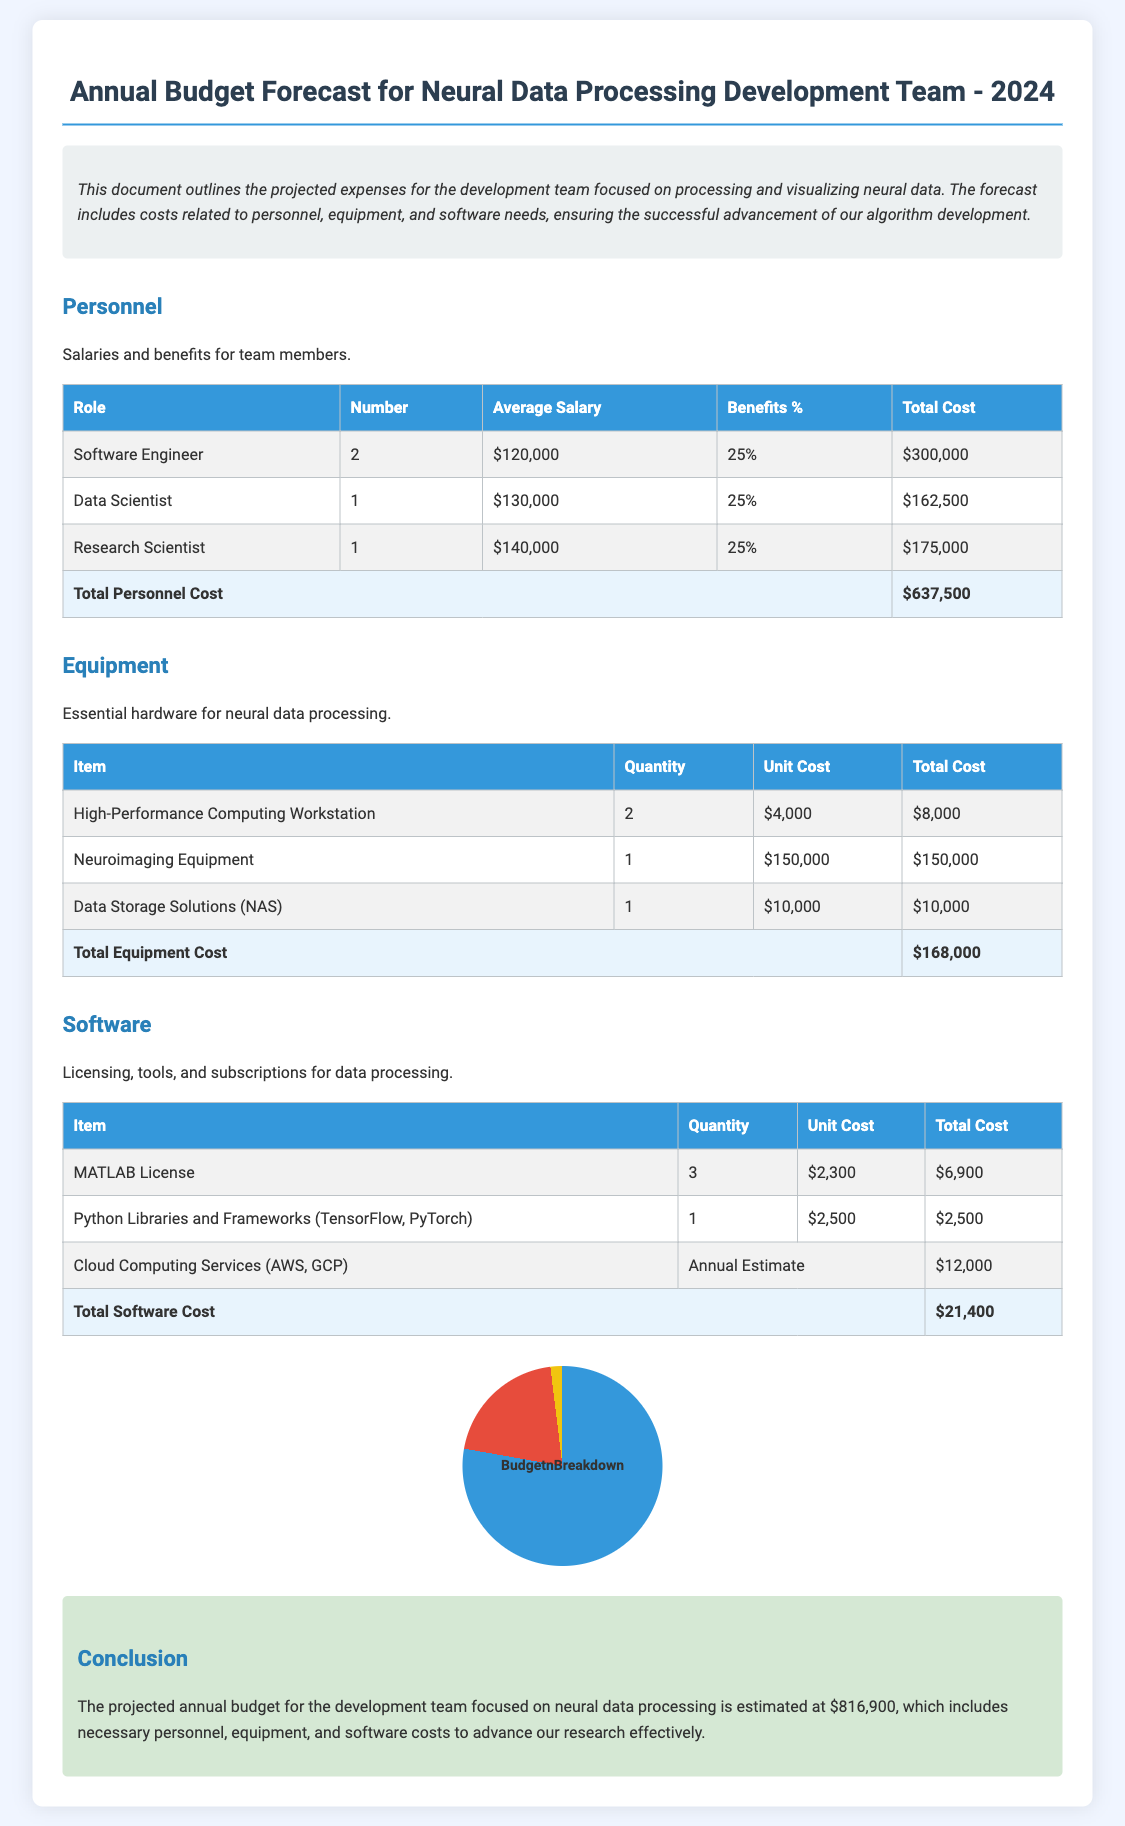What is the total personnel cost? The total personnel cost is the sum of all expenses listed under personnel, which is $637,500.
Answer: $637,500 What quantity of high-performance computing workstations is included in the budget? The budget specifies that 2 high-performance computing workstations are required.
Answer: 2 What is the average salary of a data scientist? The average salary for a data scientist is listed as $130,000.
Answer: $130,000 What is the total software cost? The total software cost is calculated from all software expenses listed, amounting to $21,400.
Answer: $21,400 How much is allocated for cloud computing services? The budget allocates $12,000 for cloud computing services.
Answer: $12,000 What is the total estimated budget for the development team? The total estimated budget for the team is the sum of all costs, which totals $816,900.
Answer: $816,900 How many roles are detailed in the personnel section? There are 3 different roles detailed in the personnel section: Software Engineer, Data Scientist, and Research Scientist.
Answer: 3 What percentage of benefits is applied to salaries? The benefits percentage applied to the salaries listed is 25%.
Answer: 25% What item has the highest individual cost listed in the equipment section? The Neuroimaging Equipment has the highest individual cost, priced at $150,000.
Answer: $150,000 